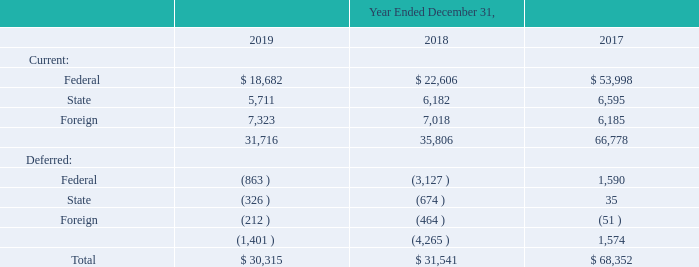The components of our income tax provision for the years ended December 31, 2019, 2018 and 2017 are as follows (in thousands):
As a result of a loss in a foreign location, we have a net operating loss carry-forward (“NOL”) of approximately $0.3 million
available to offset future income. All $0.3 million of the NOL expires in 2025. We have established a valuation allowance for this
NOL because the ability to utilize it is not more likely than not.
We have tax credit carry-forwards of approximately $5.1 million available to offset future state tax. These tax credit carry-forwards
expire in 2020 to 2029. These credits represent a deferred tax asset of $4.0 million after consideration of the federal benefit of state tax
deductions. A valuation allowance of $1.8 million has been established for these credits because the ability to use them is not more
likely than not.
At December 31, 2019 we had approximately $58.2 million of undistributed earnings and profits. The undistributed earnings and
profits are considered previously taxed income and would not be subject to U.S. income taxes upon repatriation of those earnings, in
the form of dividends. The undistributed earnings and profits are considered to be permanently reinvested, accordingly no provision
for local withholdings taxes have been provided, however, upon repatriation of those earnings, in the form of dividends, we could be
subject to additional local withholding taxes.
What is the federal tax in 2019?
Answer scale should be: thousand. 18,682. What is the foreign tax in 2019?
Answer scale should be: thousand. 7,323. What is the amount of undistributed earnings and profits in 2019? $58.2 million. Which year had the highest current federal tax? 53,998> 22,606> 18,682
Answer: 2017. What is the change in current federal taxes between 2018 and 2019?
Answer scale should be: thousand. 18,682-22,606
Answer: -3924. What is the change in tax payable between 2017 and 2018?
Answer scale should be: thousand. 68,352-31,541
Answer: 36811. 